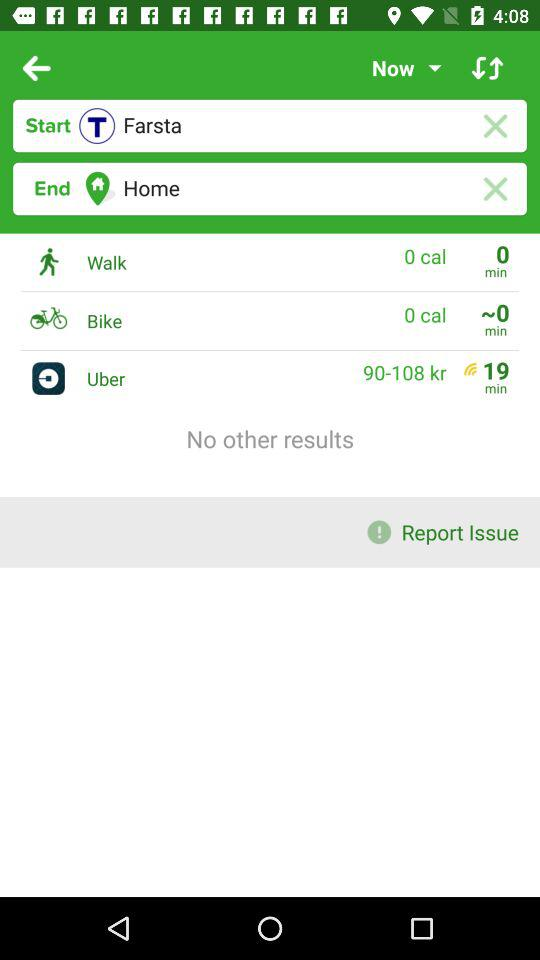What is the destination point? The destination point is home. 